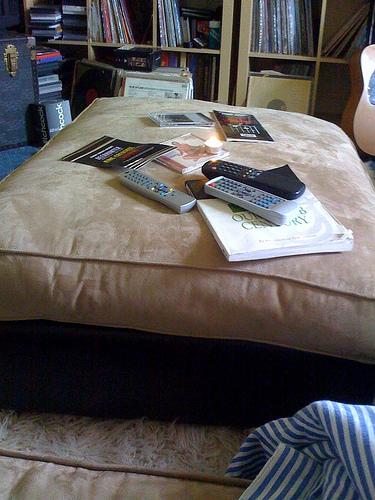How many remotes are on the bed?
Answer briefly. 3. Is the bed tidy?
Concise answer only. No. Is a candle burning in the photo?
Write a very short answer. Yes. 